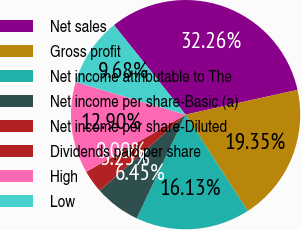Convert chart to OTSL. <chart><loc_0><loc_0><loc_500><loc_500><pie_chart><fcel>Net sales<fcel>Gross profit<fcel>Net income attributable to The<fcel>Net income per share-Basic (a)<fcel>Net income per share-Diluted<fcel>Dividends paid per share<fcel>High<fcel>Low<nl><fcel>32.26%<fcel>19.35%<fcel>16.13%<fcel>6.45%<fcel>3.23%<fcel>0.0%<fcel>12.9%<fcel>9.68%<nl></chart> 